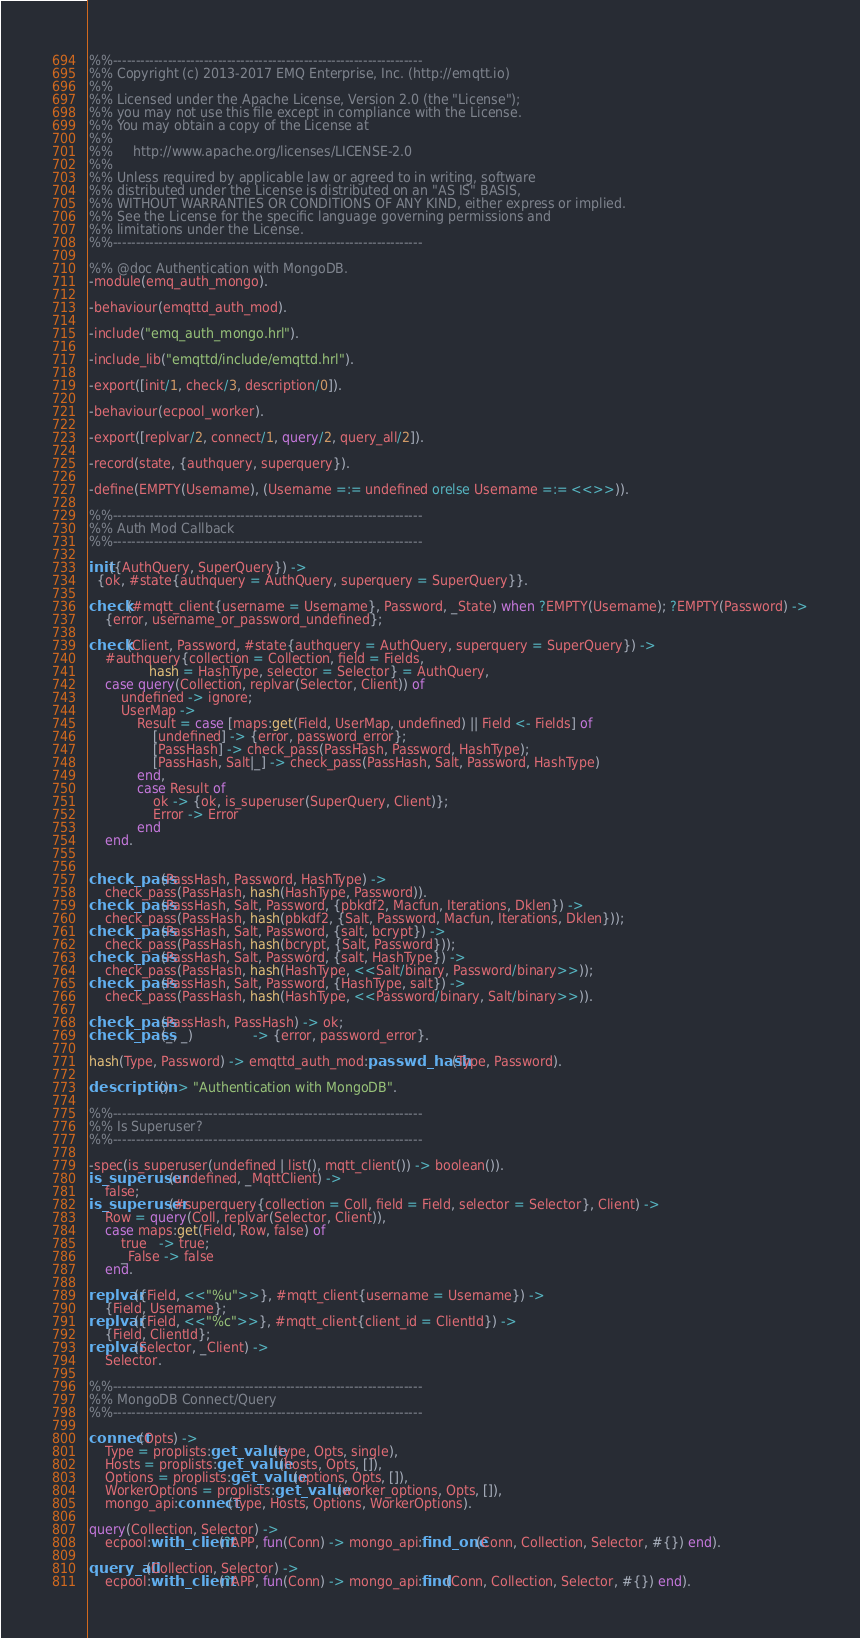<code> <loc_0><loc_0><loc_500><loc_500><_Erlang_>%%--------------------------------------------------------------------
%% Copyright (c) 2013-2017 EMQ Enterprise, Inc. (http://emqtt.io)
%%
%% Licensed under the Apache License, Version 2.0 (the "License");
%% you may not use this file except in compliance with the License.
%% You may obtain a copy of the License at
%%
%%     http://www.apache.org/licenses/LICENSE-2.0
%%
%% Unless required by applicable law or agreed to in writing, software
%% distributed under the License is distributed on an "AS IS" BASIS,
%% WITHOUT WARRANTIES OR CONDITIONS OF ANY KIND, either express or implied.
%% See the License for the specific language governing permissions and
%% limitations under the License.
%%--------------------------------------------------------------------

%% @doc Authentication with MongoDB.
-module(emq_auth_mongo).

-behaviour(emqttd_auth_mod).

-include("emq_auth_mongo.hrl").

-include_lib("emqttd/include/emqttd.hrl").

-export([init/1, check/3, description/0]).

-behaviour(ecpool_worker).

-export([replvar/2, connect/1, query/2, query_all/2]).

-record(state, {authquery, superquery}).
 
-define(EMPTY(Username), (Username =:= undefined orelse Username =:= <<>>)).

%%--------------------------------------------------------------------
%% Auth Mod Callback
%%--------------------------------------------------------------------

init({AuthQuery, SuperQuery}) ->
  {ok, #state{authquery = AuthQuery, superquery = SuperQuery}}.

check(#mqtt_client{username = Username}, Password, _State) when ?EMPTY(Username); ?EMPTY(Password) ->
    {error, username_or_password_undefined};

check(Client, Password, #state{authquery = AuthQuery, superquery = SuperQuery}) ->
    #authquery{collection = Collection, field = Fields,
               hash = HashType, selector = Selector} = AuthQuery,
    case query(Collection, replvar(Selector, Client)) of
        undefined -> ignore;
        UserMap ->
            Result = case [maps:get(Field, UserMap, undefined) || Field <- Fields] of
                [undefined] -> {error, password_error};
                [PassHash] -> check_pass(PassHash, Password, HashType);
                [PassHash, Salt|_] -> check_pass(PassHash, Salt, Password, HashType)
            end,
            case Result of
                ok -> {ok, is_superuser(SuperQuery, Client)};
                Error -> Error
            end
    end.


check_pass(PassHash, Password, HashType) ->
    check_pass(PassHash, hash(HashType, Password)).
check_pass(PassHash, Salt, Password, {pbkdf2, Macfun, Iterations, Dklen}) ->
    check_pass(PassHash, hash(pbkdf2, {Salt, Password, Macfun, Iterations, Dklen}));
check_pass(PassHash, Salt, Password, {salt, bcrypt}) ->
    check_pass(PassHash, hash(bcrypt, {Salt, Password}));
check_pass(PassHash, Salt, Password, {salt, HashType}) ->
    check_pass(PassHash, hash(HashType, <<Salt/binary, Password/binary>>));
check_pass(PassHash, Salt, Password, {HashType, salt}) ->
    check_pass(PassHash, hash(HashType, <<Password/binary, Salt/binary>>)).

check_pass(PassHash, PassHash) -> ok;
check_pass(_, _)               -> {error, password_error}. 

hash(Type, Password) -> emqttd_auth_mod:passwd_hash(Type, Password).

description() -> "Authentication with MongoDB".

%%--------------------------------------------------------------------
%% Is Superuser?
%%--------------------------------------------------------------------

-spec(is_superuser(undefined | list(), mqtt_client()) -> boolean()).
is_superuser(undefined, _MqttClient) ->
    false;
is_superuser(#superquery{collection = Coll, field = Field, selector = Selector}, Client) ->
    Row = query(Coll, replvar(Selector, Client)),
    case maps:get(Field, Row, false) of
        true   -> true;
        _False -> false
    end.

replvar({Field, <<"%u">>}, #mqtt_client{username = Username}) ->
    {Field, Username};
replvar({Field, <<"%c">>}, #mqtt_client{client_id = ClientId}) ->
    {Field, ClientId};
replvar(Selector, _Client) ->
    Selector.

%%--------------------------------------------------------------------
%% MongoDB Connect/Query
%%--------------------------------------------------------------------

connect(Opts) ->
    Type = proplists:get_value(type, Opts, single),
    Hosts = proplists:get_value(hosts, Opts, []),
    Options = proplists:get_value(options, Opts, []),
    WorkerOptions = proplists:get_value(worker_options, Opts, []),
    mongo_api:connect(Type, Hosts, Options, WorkerOptions).

query(Collection, Selector) ->
    ecpool:with_client(?APP, fun(Conn) -> mongo_api:find_one(Conn, Collection, Selector, #{}) end).

query_all(Collection, Selector) ->
    ecpool:with_client(?APP, fun(Conn) -> mongo_api:find(Conn, Collection, Selector, #{}) end).

</code> 